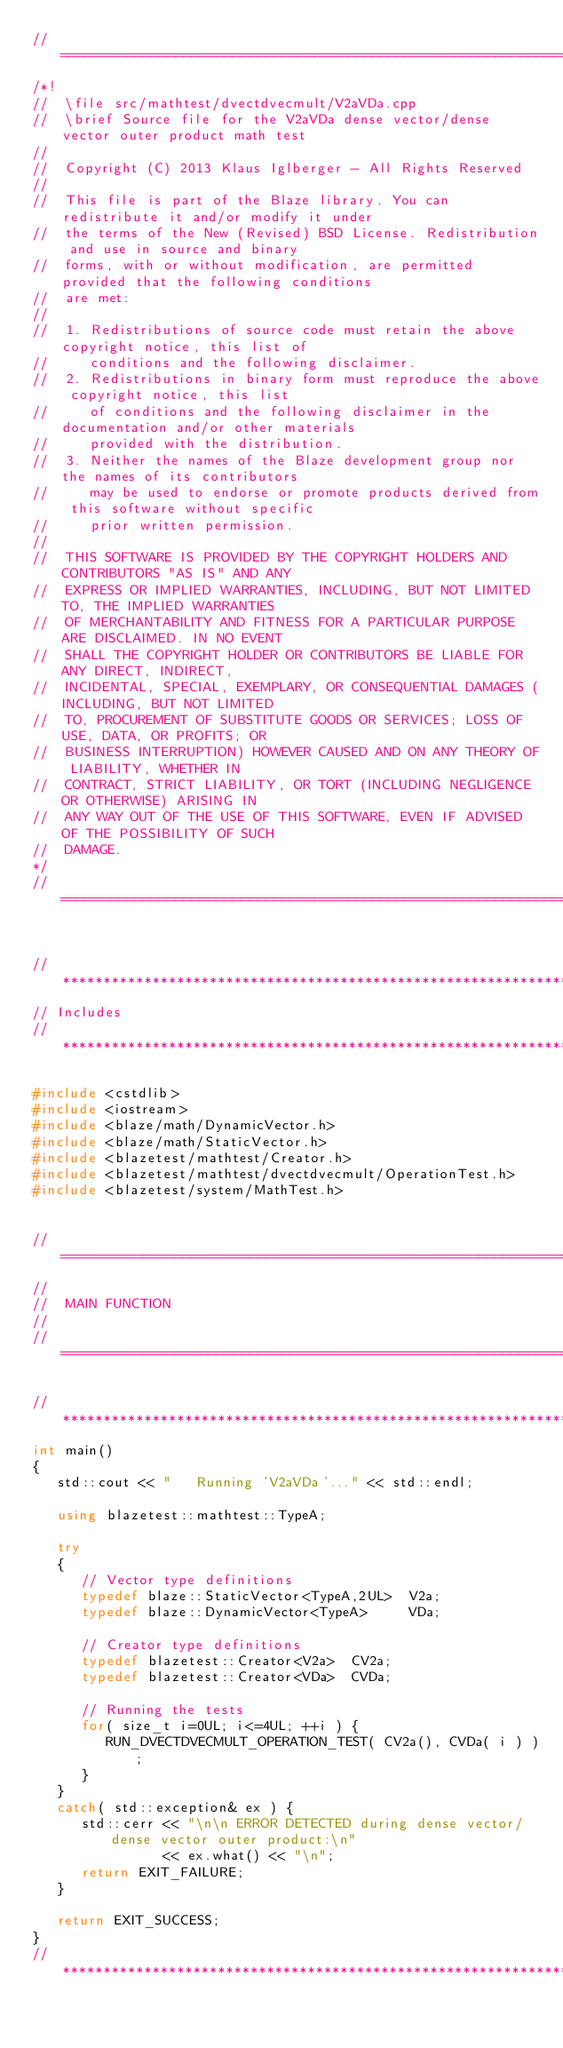Convert code to text. <code><loc_0><loc_0><loc_500><loc_500><_C++_>//=================================================================================================
/*!
//  \file src/mathtest/dvectdvecmult/V2aVDa.cpp
//  \brief Source file for the V2aVDa dense vector/dense vector outer product math test
//
//  Copyright (C) 2013 Klaus Iglberger - All Rights Reserved
//
//  This file is part of the Blaze library. You can redistribute it and/or modify it under
//  the terms of the New (Revised) BSD License. Redistribution and use in source and binary
//  forms, with or without modification, are permitted provided that the following conditions
//  are met:
//
//  1. Redistributions of source code must retain the above copyright notice, this list of
//     conditions and the following disclaimer.
//  2. Redistributions in binary form must reproduce the above copyright notice, this list
//     of conditions and the following disclaimer in the documentation and/or other materials
//     provided with the distribution.
//  3. Neither the names of the Blaze development group nor the names of its contributors
//     may be used to endorse or promote products derived from this software without specific
//     prior written permission.
//
//  THIS SOFTWARE IS PROVIDED BY THE COPYRIGHT HOLDERS AND CONTRIBUTORS "AS IS" AND ANY
//  EXPRESS OR IMPLIED WARRANTIES, INCLUDING, BUT NOT LIMITED TO, THE IMPLIED WARRANTIES
//  OF MERCHANTABILITY AND FITNESS FOR A PARTICULAR PURPOSE ARE DISCLAIMED. IN NO EVENT
//  SHALL THE COPYRIGHT HOLDER OR CONTRIBUTORS BE LIABLE FOR ANY DIRECT, INDIRECT,
//  INCIDENTAL, SPECIAL, EXEMPLARY, OR CONSEQUENTIAL DAMAGES (INCLUDING, BUT NOT LIMITED
//  TO, PROCUREMENT OF SUBSTITUTE GOODS OR SERVICES; LOSS OF USE, DATA, OR PROFITS; OR
//  BUSINESS INTERRUPTION) HOWEVER CAUSED AND ON ANY THEORY OF LIABILITY, WHETHER IN
//  CONTRACT, STRICT LIABILITY, OR TORT (INCLUDING NEGLIGENCE OR OTHERWISE) ARISING IN
//  ANY WAY OUT OF THE USE OF THIS SOFTWARE, EVEN IF ADVISED OF THE POSSIBILITY OF SUCH
//  DAMAGE.
*/
//=================================================================================================


//*************************************************************************************************
// Includes
//*************************************************************************************************

#include <cstdlib>
#include <iostream>
#include <blaze/math/DynamicVector.h>
#include <blaze/math/StaticVector.h>
#include <blazetest/mathtest/Creator.h>
#include <blazetest/mathtest/dvectdvecmult/OperationTest.h>
#include <blazetest/system/MathTest.h>


//=================================================================================================
//
//  MAIN FUNCTION
//
//=================================================================================================

//*************************************************************************************************
int main()
{
   std::cout << "   Running 'V2aVDa'..." << std::endl;

   using blazetest::mathtest::TypeA;

   try
   {
      // Vector type definitions
      typedef blaze::StaticVector<TypeA,2UL>  V2a;
      typedef blaze::DynamicVector<TypeA>     VDa;

      // Creator type definitions
      typedef blazetest::Creator<V2a>  CV2a;
      typedef blazetest::Creator<VDa>  CVDa;

      // Running the tests
      for( size_t i=0UL; i<=4UL; ++i ) {
         RUN_DVECTDVECMULT_OPERATION_TEST( CV2a(), CVDa( i ) );
      }
   }
   catch( std::exception& ex ) {
      std::cerr << "\n\n ERROR DETECTED during dense vector/dense vector outer product:\n"
                << ex.what() << "\n";
      return EXIT_FAILURE;
   }

   return EXIT_SUCCESS;
}
//*************************************************************************************************
</code> 